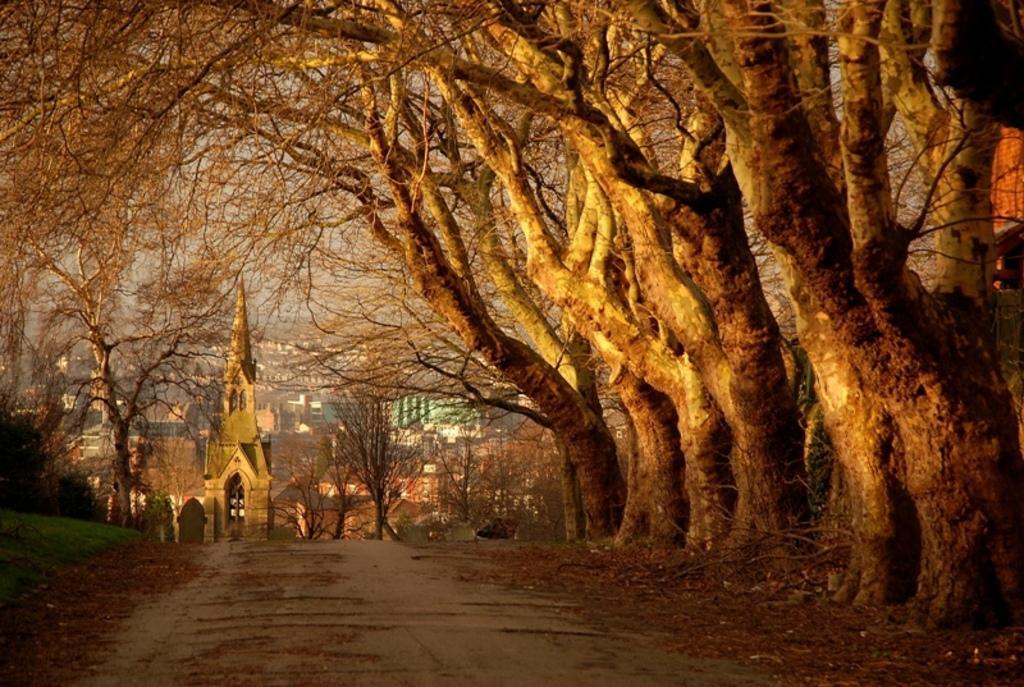Can you describe this image briefly? In the foreground of this image, there is road and on the right, there are trees without leaves. On the left, there is grassland and trees. In the background, there are trees, buildings and the sky. 